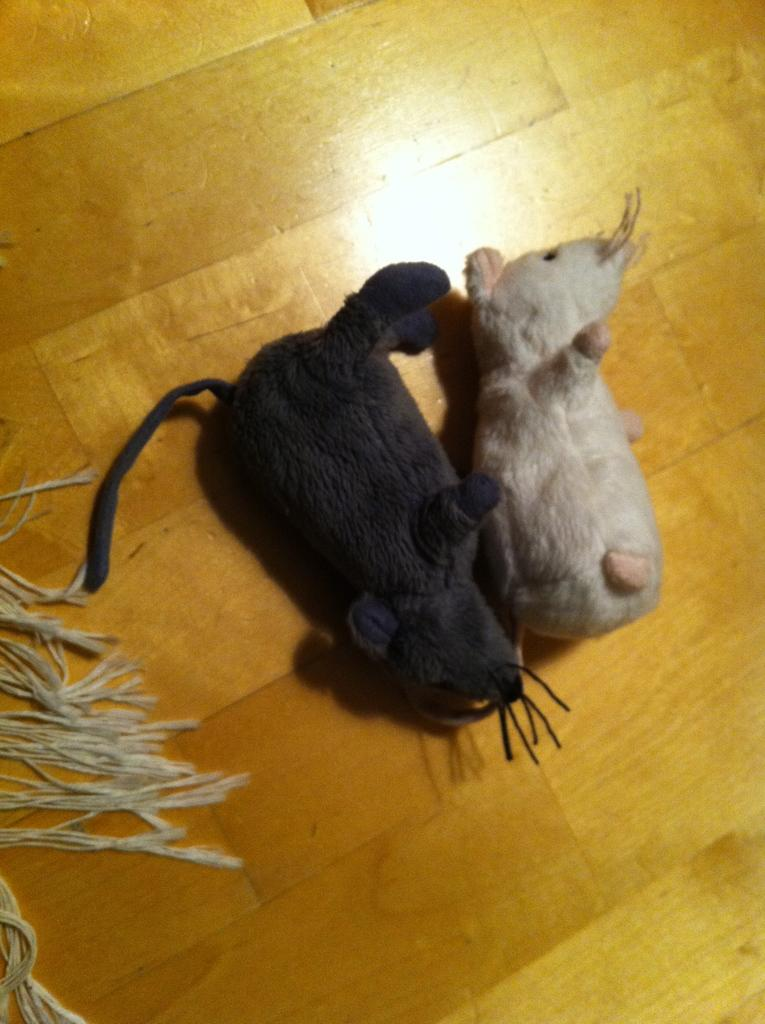What type of toys are visible in the image? There are black and white toys in the image. Where are the toys located? The toys are on a wooden floor. What is present on the left side of the toys? There is a rag on the left side of the toys. What type of insect can be seen crawling on the boundary of the image? There is no insect present in the image, and therefore no such activity can be observed. 